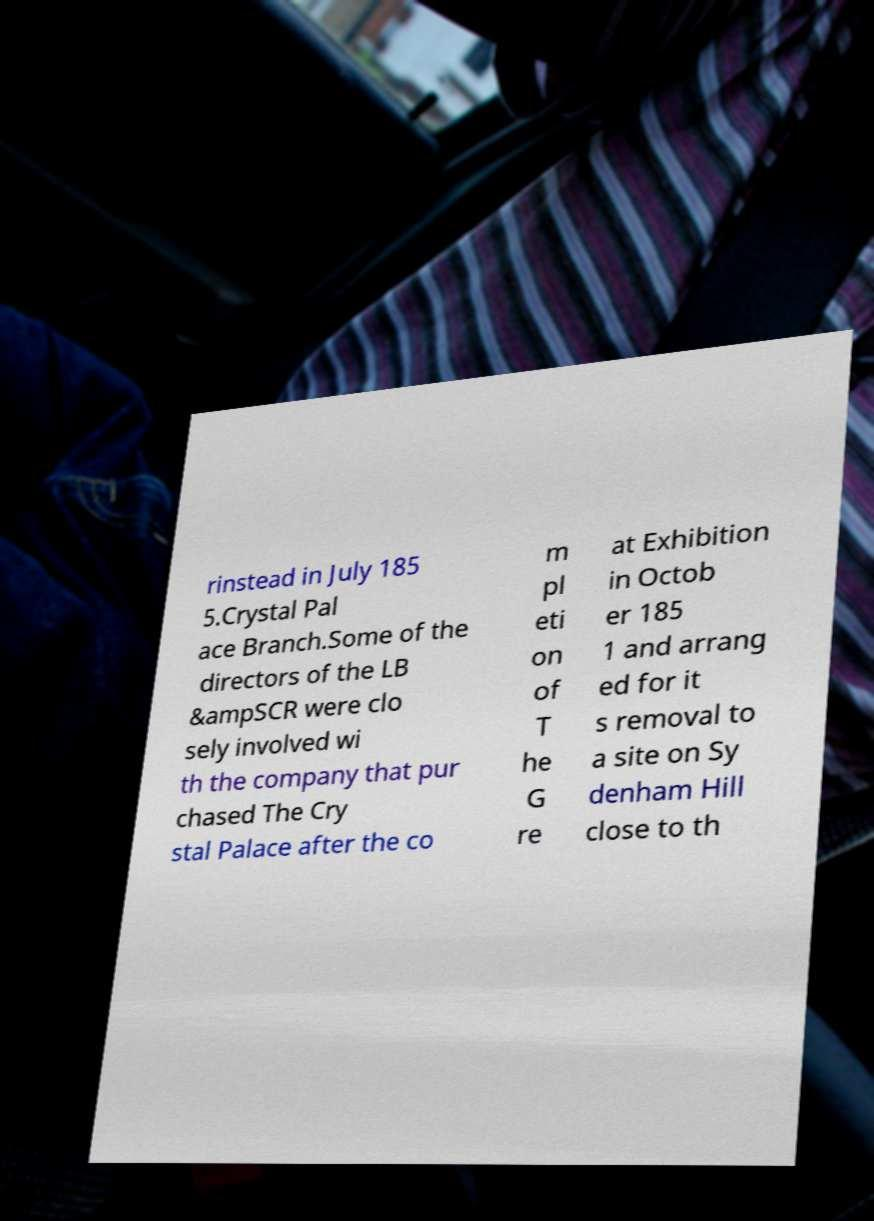Could you extract and type out the text from this image? rinstead in July 185 5.Crystal Pal ace Branch.Some of the directors of the LB &ampSCR were clo sely involved wi th the company that pur chased The Cry stal Palace after the co m pl eti on of T he G re at Exhibition in Octob er 185 1 and arrang ed for it s removal to a site on Sy denham Hill close to th 